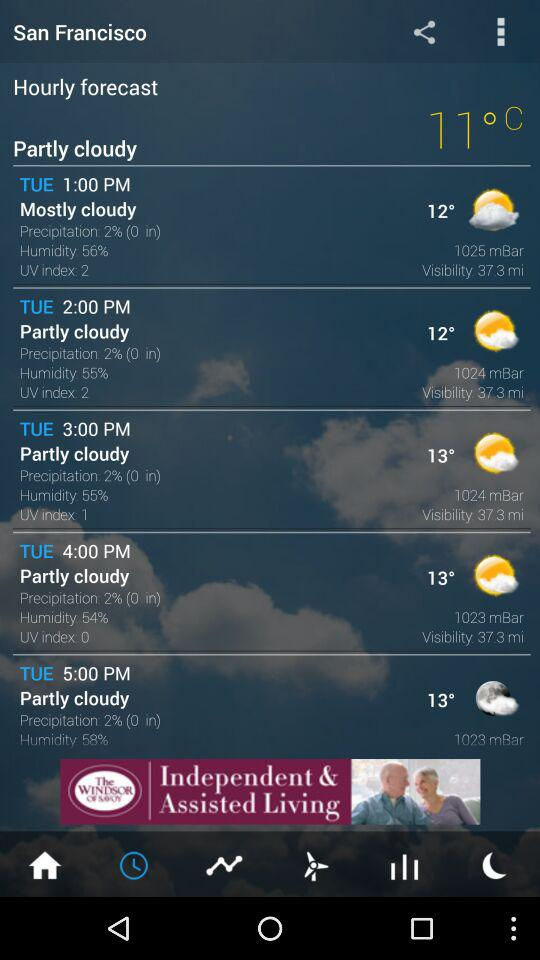What is the visibility at 1:00 PM on Tuesday? The visibility is 37.3 miles. 